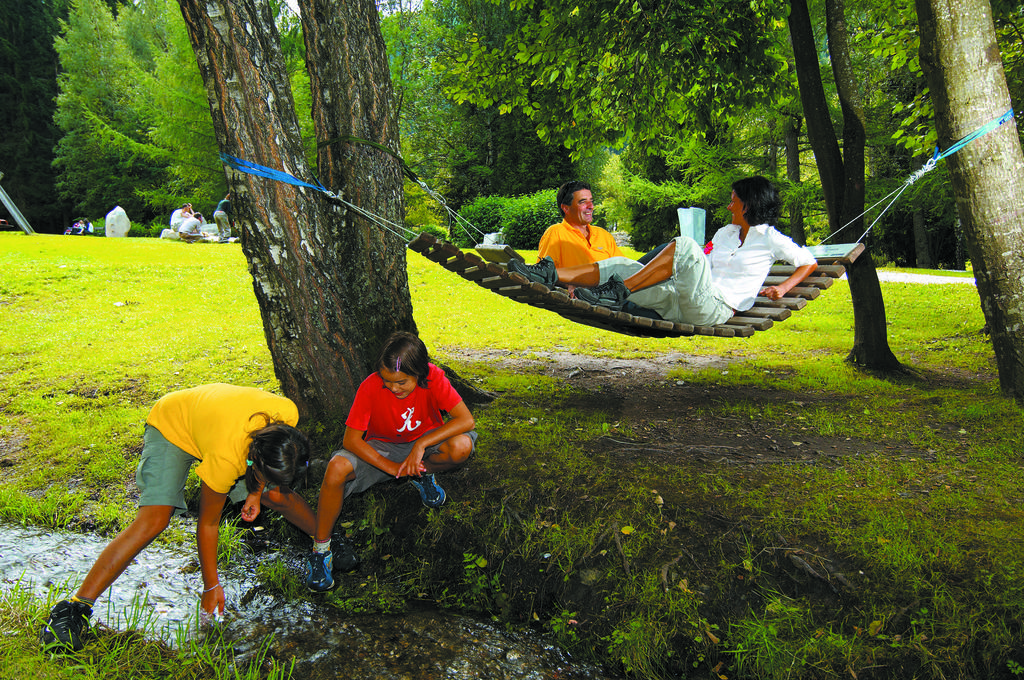What activity are the two persons engaged in? The two persons are on a swing. Where are the two people near the water? The two people are near the water. What is the location of the people on the grass? The people are on the grass. What type of vegetation can be seen in the image? There are trees and flowers in the image. What type of stove is visible in the image? There is no stove present in the image. Is the canvas used for painting in the image? There is no canvas or painting activity depicted in the image. 